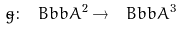<formula> <loc_0><loc_0><loc_500><loc_500>\tilde { g } \colon \ B b b { A } ^ { 2 } \rightarrow \ B b b { A } ^ { 3 }</formula> 